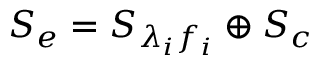Convert formula to latex. <formula><loc_0><loc_0><loc_500><loc_500>{ { S } _ { e } } = { { S } _ { { \lambda } _ { i } { f } _ { i } } } \oplus { { S _ { c } } }</formula> 